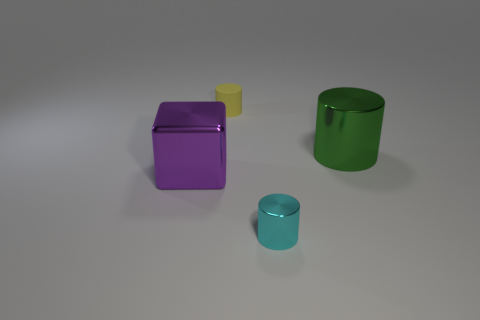Can you tell me the colors of the objects and their relative positions to each other? Certainly! In the image, we have four objects: a large purple block, a small yellow matte cylinder, a larger green metallic cylinder, and a smaller teal metallic cylinder. The purple block is positioned towards the back with the small yellow cylinder in front of it to the right. The larger green cylinder is towards the back left, and the smaller teal cylinder is up front, a bit to the right. 